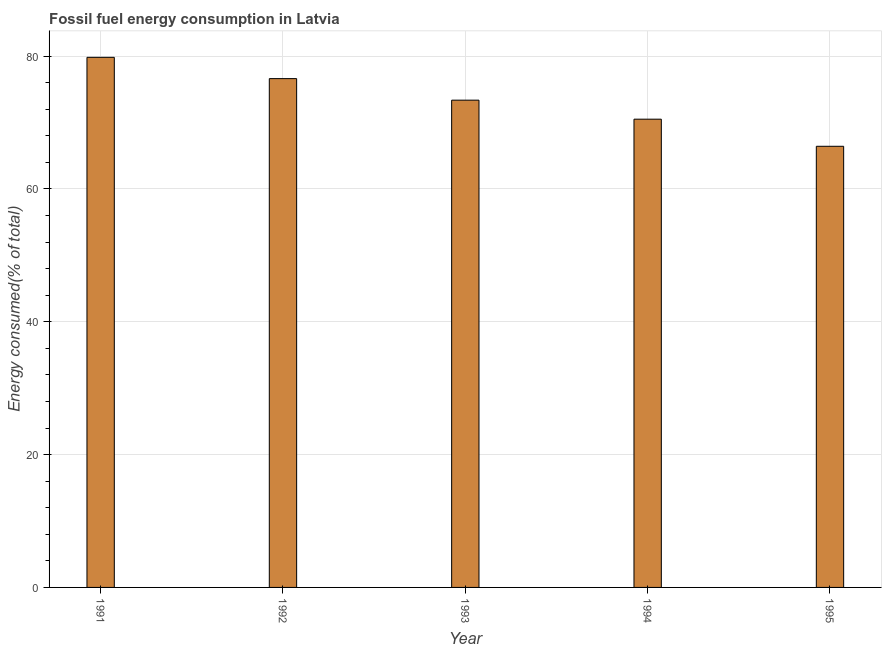Does the graph contain grids?
Your response must be concise. Yes. What is the title of the graph?
Make the answer very short. Fossil fuel energy consumption in Latvia. What is the label or title of the Y-axis?
Give a very brief answer. Energy consumed(% of total). What is the fossil fuel energy consumption in 1991?
Your response must be concise. 79.82. Across all years, what is the maximum fossil fuel energy consumption?
Ensure brevity in your answer.  79.82. Across all years, what is the minimum fossil fuel energy consumption?
Offer a very short reply. 66.43. In which year was the fossil fuel energy consumption maximum?
Your answer should be very brief. 1991. What is the sum of the fossil fuel energy consumption?
Keep it short and to the point. 366.74. What is the difference between the fossil fuel energy consumption in 1994 and 1995?
Ensure brevity in your answer.  4.08. What is the average fossil fuel energy consumption per year?
Offer a terse response. 73.35. What is the median fossil fuel energy consumption?
Offer a very short reply. 73.37. In how many years, is the fossil fuel energy consumption greater than 64 %?
Keep it short and to the point. 5. What is the ratio of the fossil fuel energy consumption in 1991 to that in 1995?
Make the answer very short. 1.2. Is the difference between the fossil fuel energy consumption in 1991 and 1994 greater than the difference between any two years?
Your answer should be very brief. No. What is the difference between the highest and the second highest fossil fuel energy consumption?
Give a very brief answer. 3.21. Is the sum of the fossil fuel energy consumption in 1993 and 1994 greater than the maximum fossil fuel energy consumption across all years?
Make the answer very short. Yes. How many bars are there?
Provide a succinct answer. 5. How many years are there in the graph?
Your answer should be very brief. 5. What is the Energy consumed(% of total) of 1991?
Give a very brief answer. 79.82. What is the Energy consumed(% of total) in 1992?
Provide a succinct answer. 76.61. What is the Energy consumed(% of total) of 1993?
Make the answer very short. 73.37. What is the Energy consumed(% of total) of 1994?
Provide a succinct answer. 70.51. What is the Energy consumed(% of total) of 1995?
Ensure brevity in your answer.  66.43. What is the difference between the Energy consumed(% of total) in 1991 and 1992?
Provide a succinct answer. 3.21. What is the difference between the Energy consumed(% of total) in 1991 and 1993?
Your answer should be very brief. 6.45. What is the difference between the Energy consumed(% of total) in 1991 and 1994?
Provide a succinct answer. 9.31. What is the difference between the Energy consumed(% of total) in 1991 and 1995?
Your answer should be very brief. 13.4. What is the difference between the Energy consumed(% of total) in 1992 and 1993?
Ensure brevity in your answer.  3.24. What is the difference between the Energy consumed(% of total) in 1992 and 1994?
Make the answer very short. 6.11. What is the difference between the Energy consumed(% of total) in 1992 and 1995?
Give a very brief answer. 10.19. What is the difference between the Energy consumed(% of total) in 1993 and 1994?
Provide a succinct answer. 2.86. What is the difference between the Energy consumed(% of total) in 1993 and 1995?
Ensure brevity in your answer.  6.95. What is the difference between the Energy consumed(% of total) in 1994 and 1995?
Keep it short and to the point. 4.08. What is the ratio of the Energy consumed(% of total) in 1991 to that in 1992?
Provide a short and direct response. 1.04. What is the ratio of the Energy consumed(% of total) in 1991 to that in 1993?
Give a very brief answer. 1.09. What is the ratio of the Energy consumed(% of total) in 1991 to that in 1994?
Make the answer very short. 1.13. What is the ratio of the Energy consumed(% of total) in 1991 to that in 1995?
Your response must be concise. 1.2. What is the ratio of the Energy consumed(% of total) in 1992 to that in 1993?
Your response must be concise. 1.04. What is the ratio of the Energy consumed(% of total) in 1992 to that in 1994?
Provide a short and direct response. 1.09. What is the ratio of the Energy consumed(% of total) in 1992 to that in 1995?
Your answer should be very brief. 1.15. What is the ratio of the Energy consumed(% of total) in 1993 to that in 1994?
Ensure brevity in your answer.  1.04. What is the ratio of the Energy consumed(% of total) in 1993 to that in 1995?
Make the answer very short. 1.1. What is the ratio of the Energy consumed(% of total) in 1994 to that in 1995?
Offer a very short reply. 1.06. 